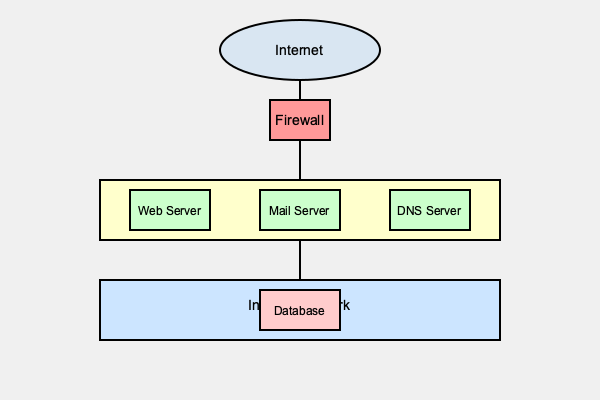Based on the network topology diagram provided, identify the most significant potential vulnerability in this network architecture and suggest a mitigation strategy that would be least disruptive to the existing setup. To answer this question, let's analyze the network topology step-by-step:

1. Internet Connection: The network is connected to the internet, which is the primary source of external threats.

2. Firewall: There's a single firewall between the internet and the internal networks. This is good for basic protection but creates a single point of failure.

3. DMZ (Demilitarized Zone): The DMZ contains public-facing servers (Web, Mail, and DNS). This is a good practice for isolating public services from the internal network.

4. Internal Network: The internal network contains a database server, which likely holds sensitive information.

5. Network Segmentation: There's basic segmentation between the DMZ and the internal network, which is good. However, there's no visible segmentation within these zones.

The most significant potential vulnerability in this setup is the single firewall acting as the only barrier between the internet, DMZ, and internal network. If this firewall is compromised or fails, it could expose both the DMZ and the internal network to attacks.

A mitigation strategy that would be least disruptive to the existing setup would be to implement a second firewall between the DMZ and the internal network. This creates a "defense in depth" approach without requiring major changes to the existing network structure.

This second firewall would:
1. Provide an additional layer of security for the internal network.
2. Allow for more granular control of traffic between the DMZ and internal network.
3. Reduce the risk of a single point of failure in the network's security.
4. Help contain potential breaches if a DMZ server is compromised.

Implementing this second firewall would require minimal changes to the existing network architecture while significantly improving the overall security posture.
Answer: Implement a second firewall between DMZ and internal network. 